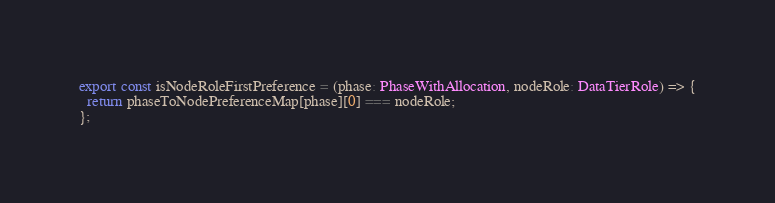<code> <loc_0><loc_0><loc_500><loc_500><_TypeScript_>export const isNodeRoleFirstPreference = (phase: PhaseWithAllocation, nodeRole: DataTierRole) => {
  return phaseToNodePreferenceMap[phase][0] === nodeRole;
};
</code> 